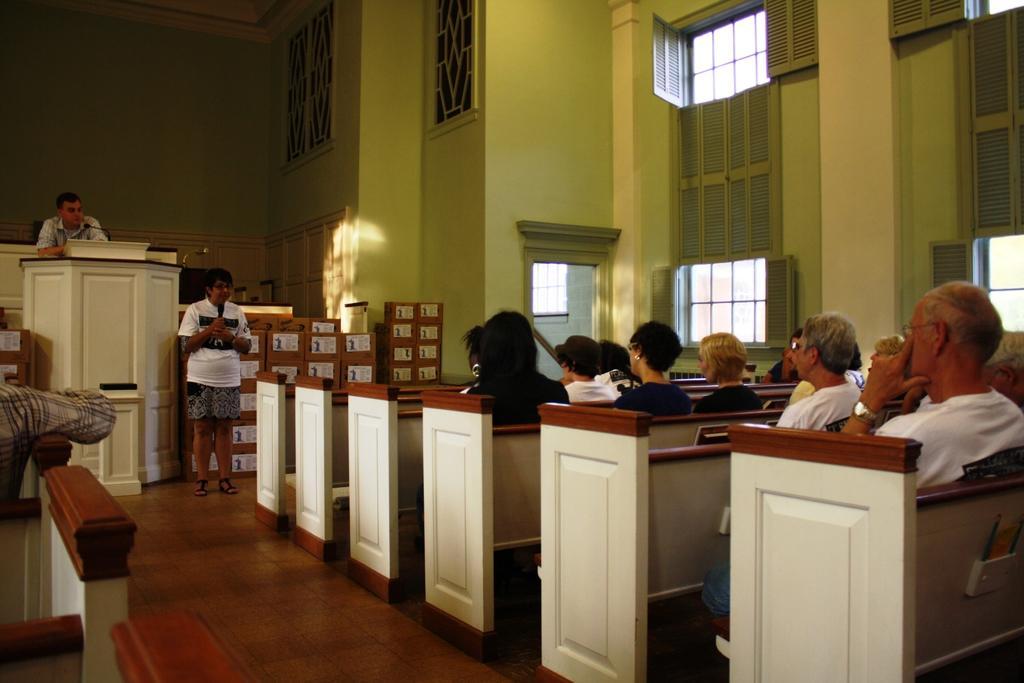Could you give a brief overview of what you see in this image? In this image I can see the group of people sitting and wearing the different color dresses. In-front of these people I can see two people. One person is in-front of the podium. On the podium I can see the mic. In the background I can see the windows to the wall. 